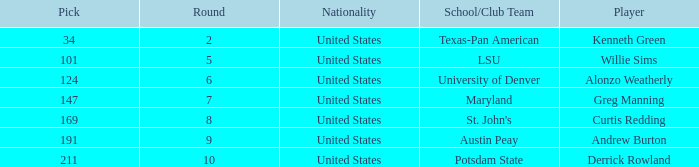What is the average Pick when the round was less than 6 for kenneth green? 34.0. 